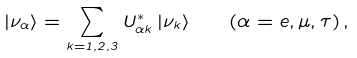<formula> <loc_0><loc_0><loc_500><loc_500>| \nu _ { \alpha } \rangle = \sum _ { k = 1 , 2 , 3 } U _ { { \alpha } k } ^ { * } \, | \nu _ { k } \rangle \quad ( \alpha = e , \mu , \tau ) \, ,</formula> 